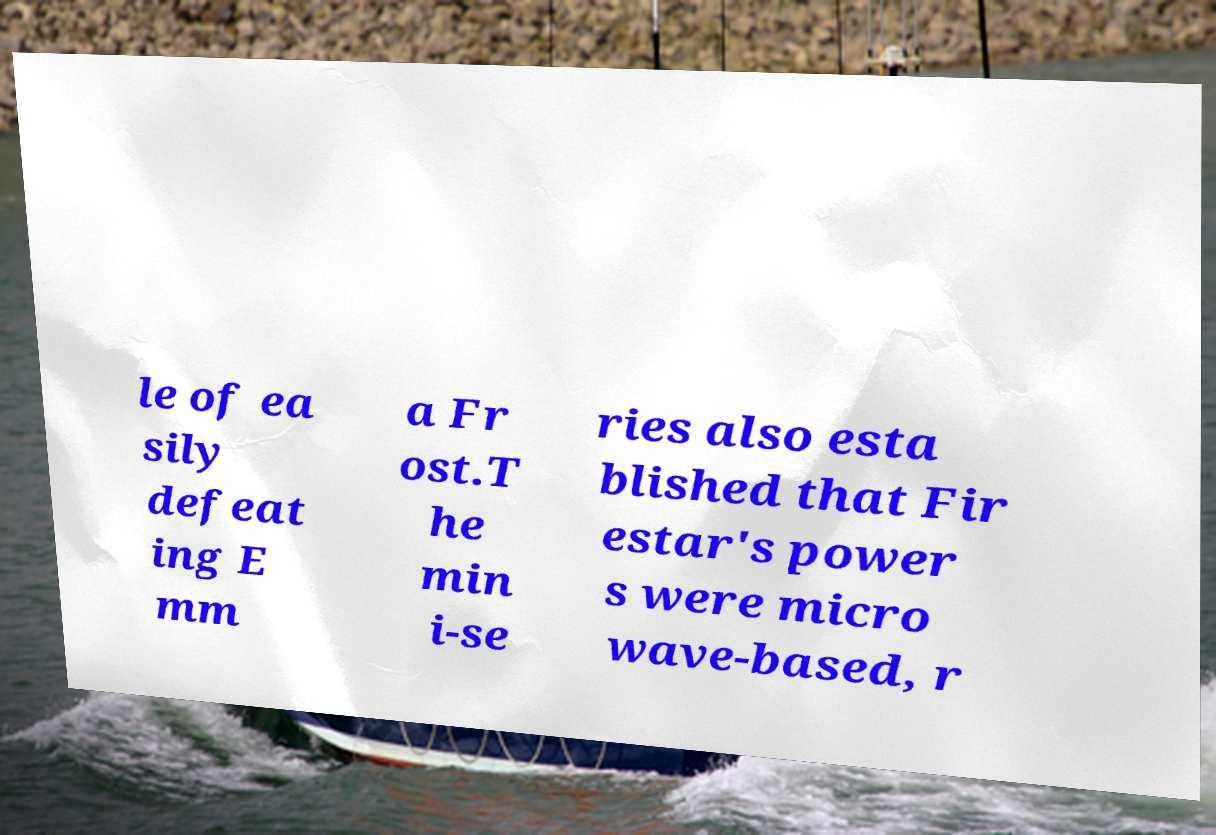Please read and relay the text visible in this image. What does it say? le of ea sily defeat ing E mm a Fr ost.T he min i-se ries also esta blished that Fir estar's power s were micro wave-based, r 